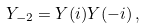Convert formula to latex. <formula><loc_0><loc_0><loc_500><loc_500>Y _ { - 2 } = Y ( i ) Y ( - i ) \, ,</formula> 